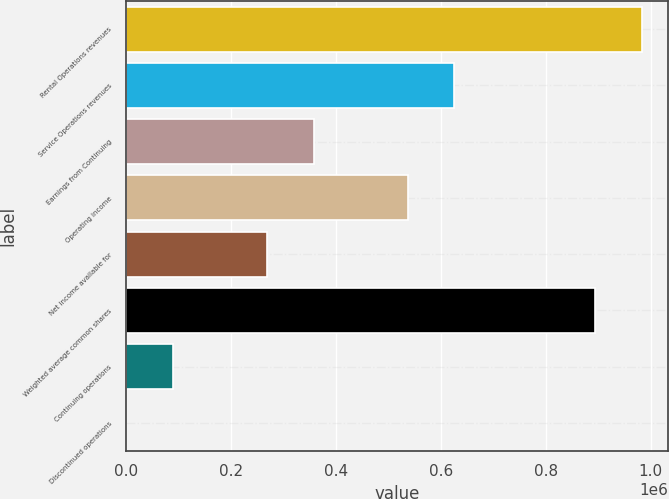Convert chart. <chart><loc_0><loc_0><loc_500><loc_500><bar_chart><fcel>Rental Operations revenues<fcel>Service Operations revenues<fcel>Earnings from Continuing<fcel>Operating income<fcel>Net income available for<fcel>Weighted average common shares<fcel>Continuing operations<fcel>Discontinued operations<nl><fcel>983608<fcel>625932<fcel>357676<fcel>536513<fcel>268257<fcel>894189<fcel>89419<fcel>0.12<nl></chart> 